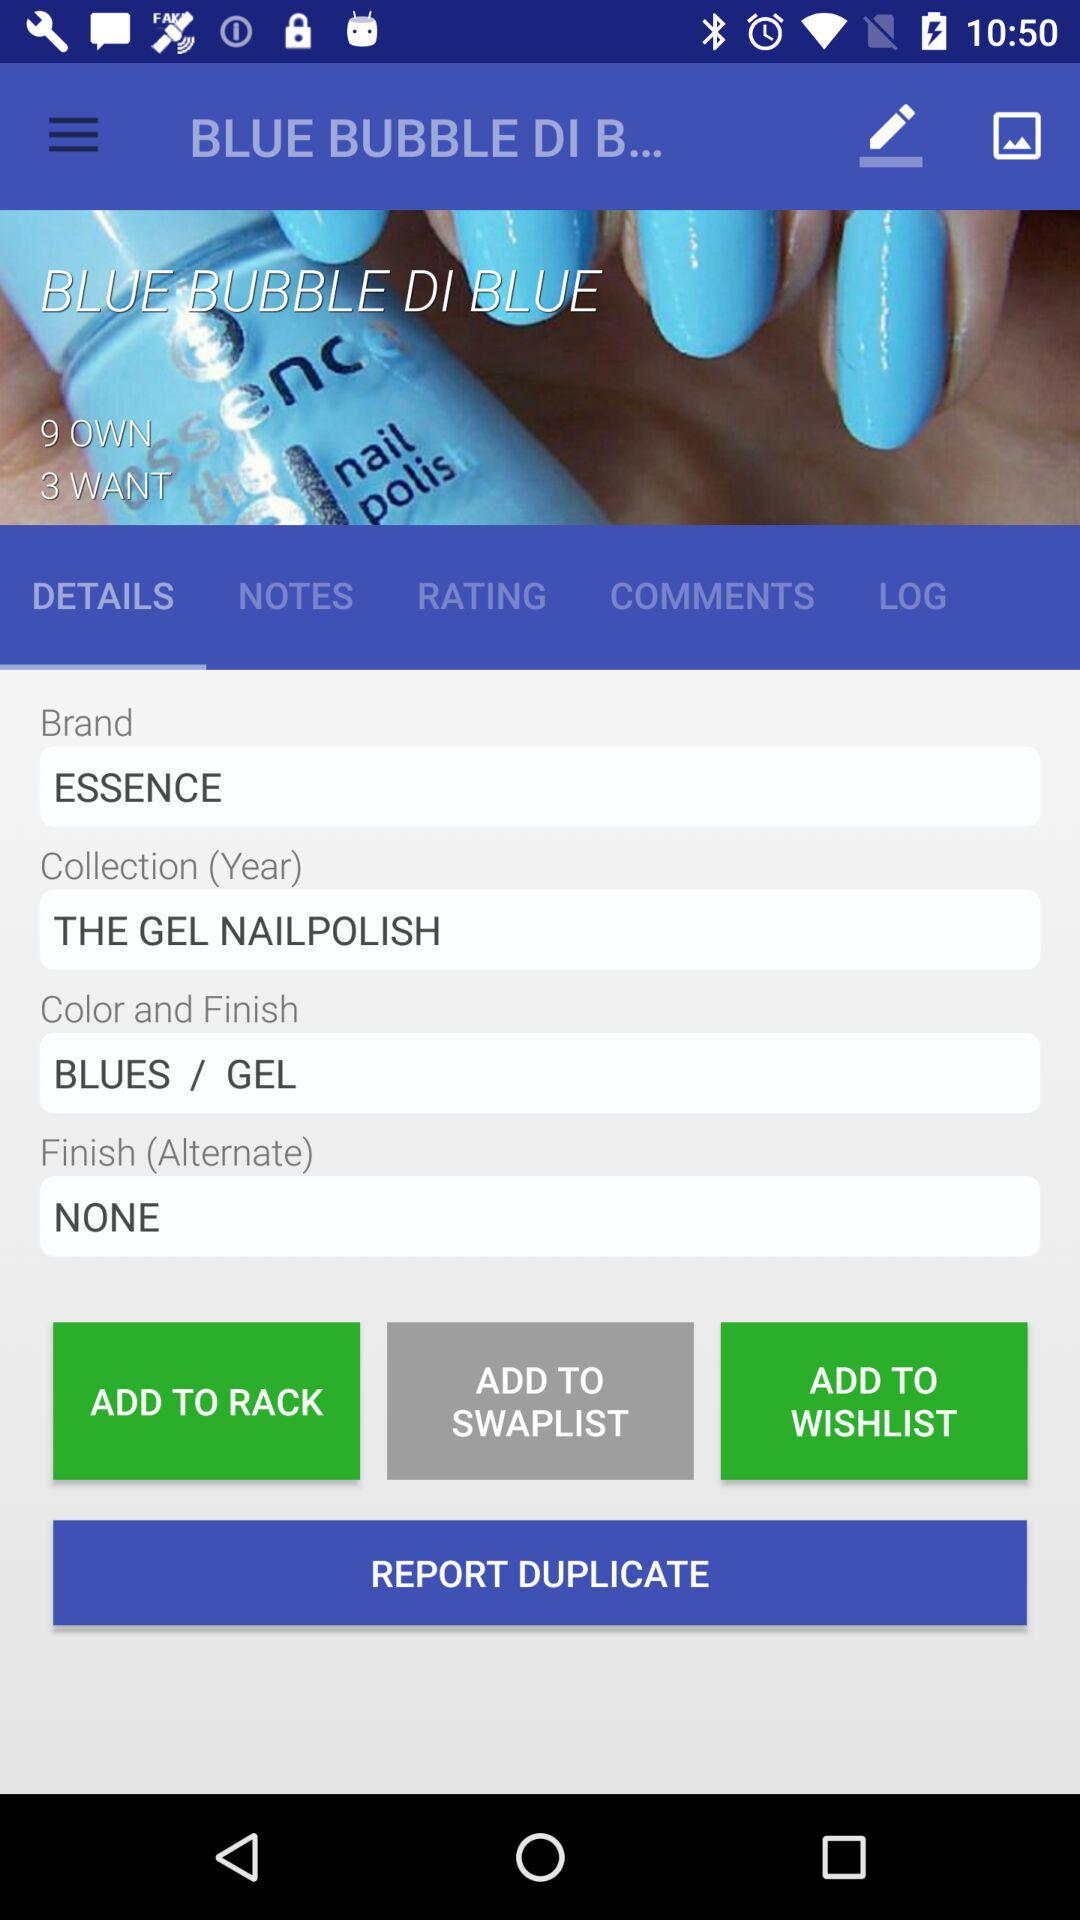What is the collection name? The collection name is "THE GEL NAILPOLISH". 